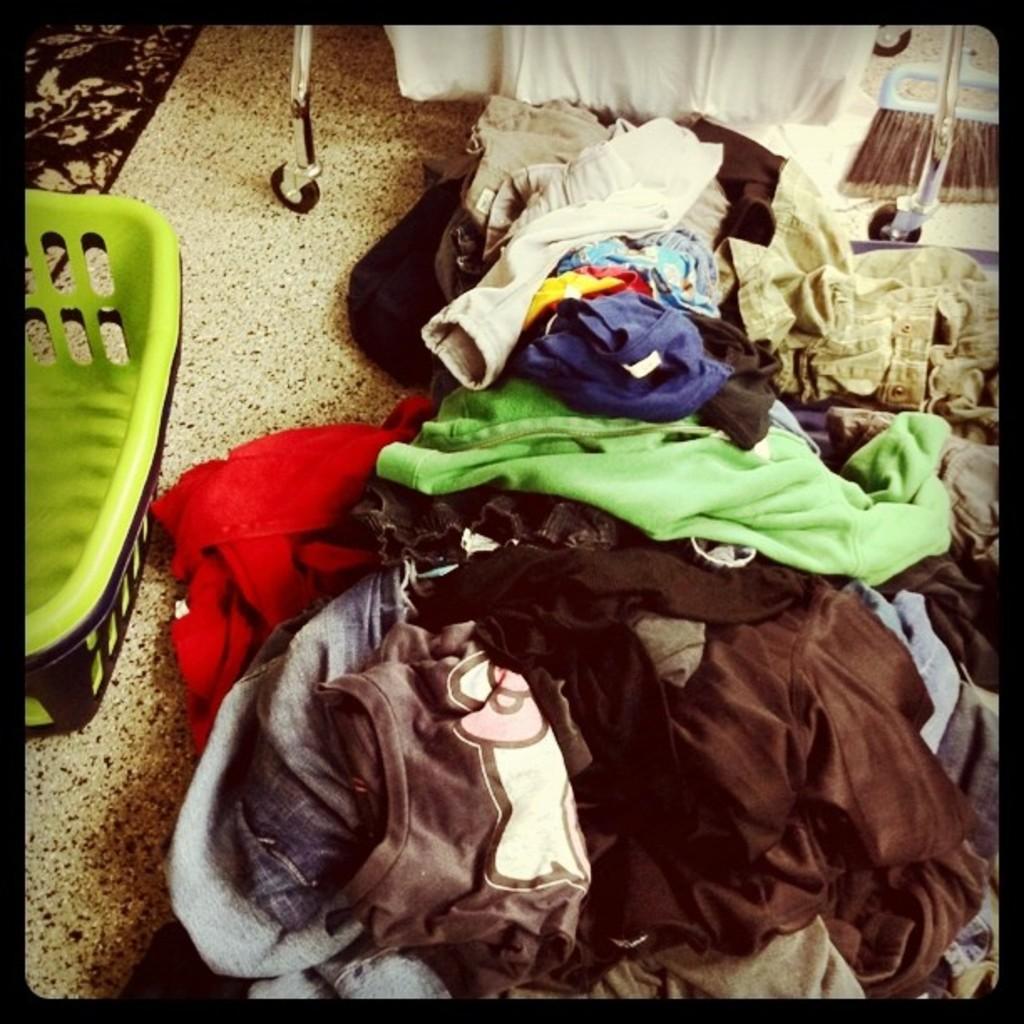In one or two sentences, can you explain what this image depicts? In this image I can see the clothes on the floor. On the left side I can see a basket. 